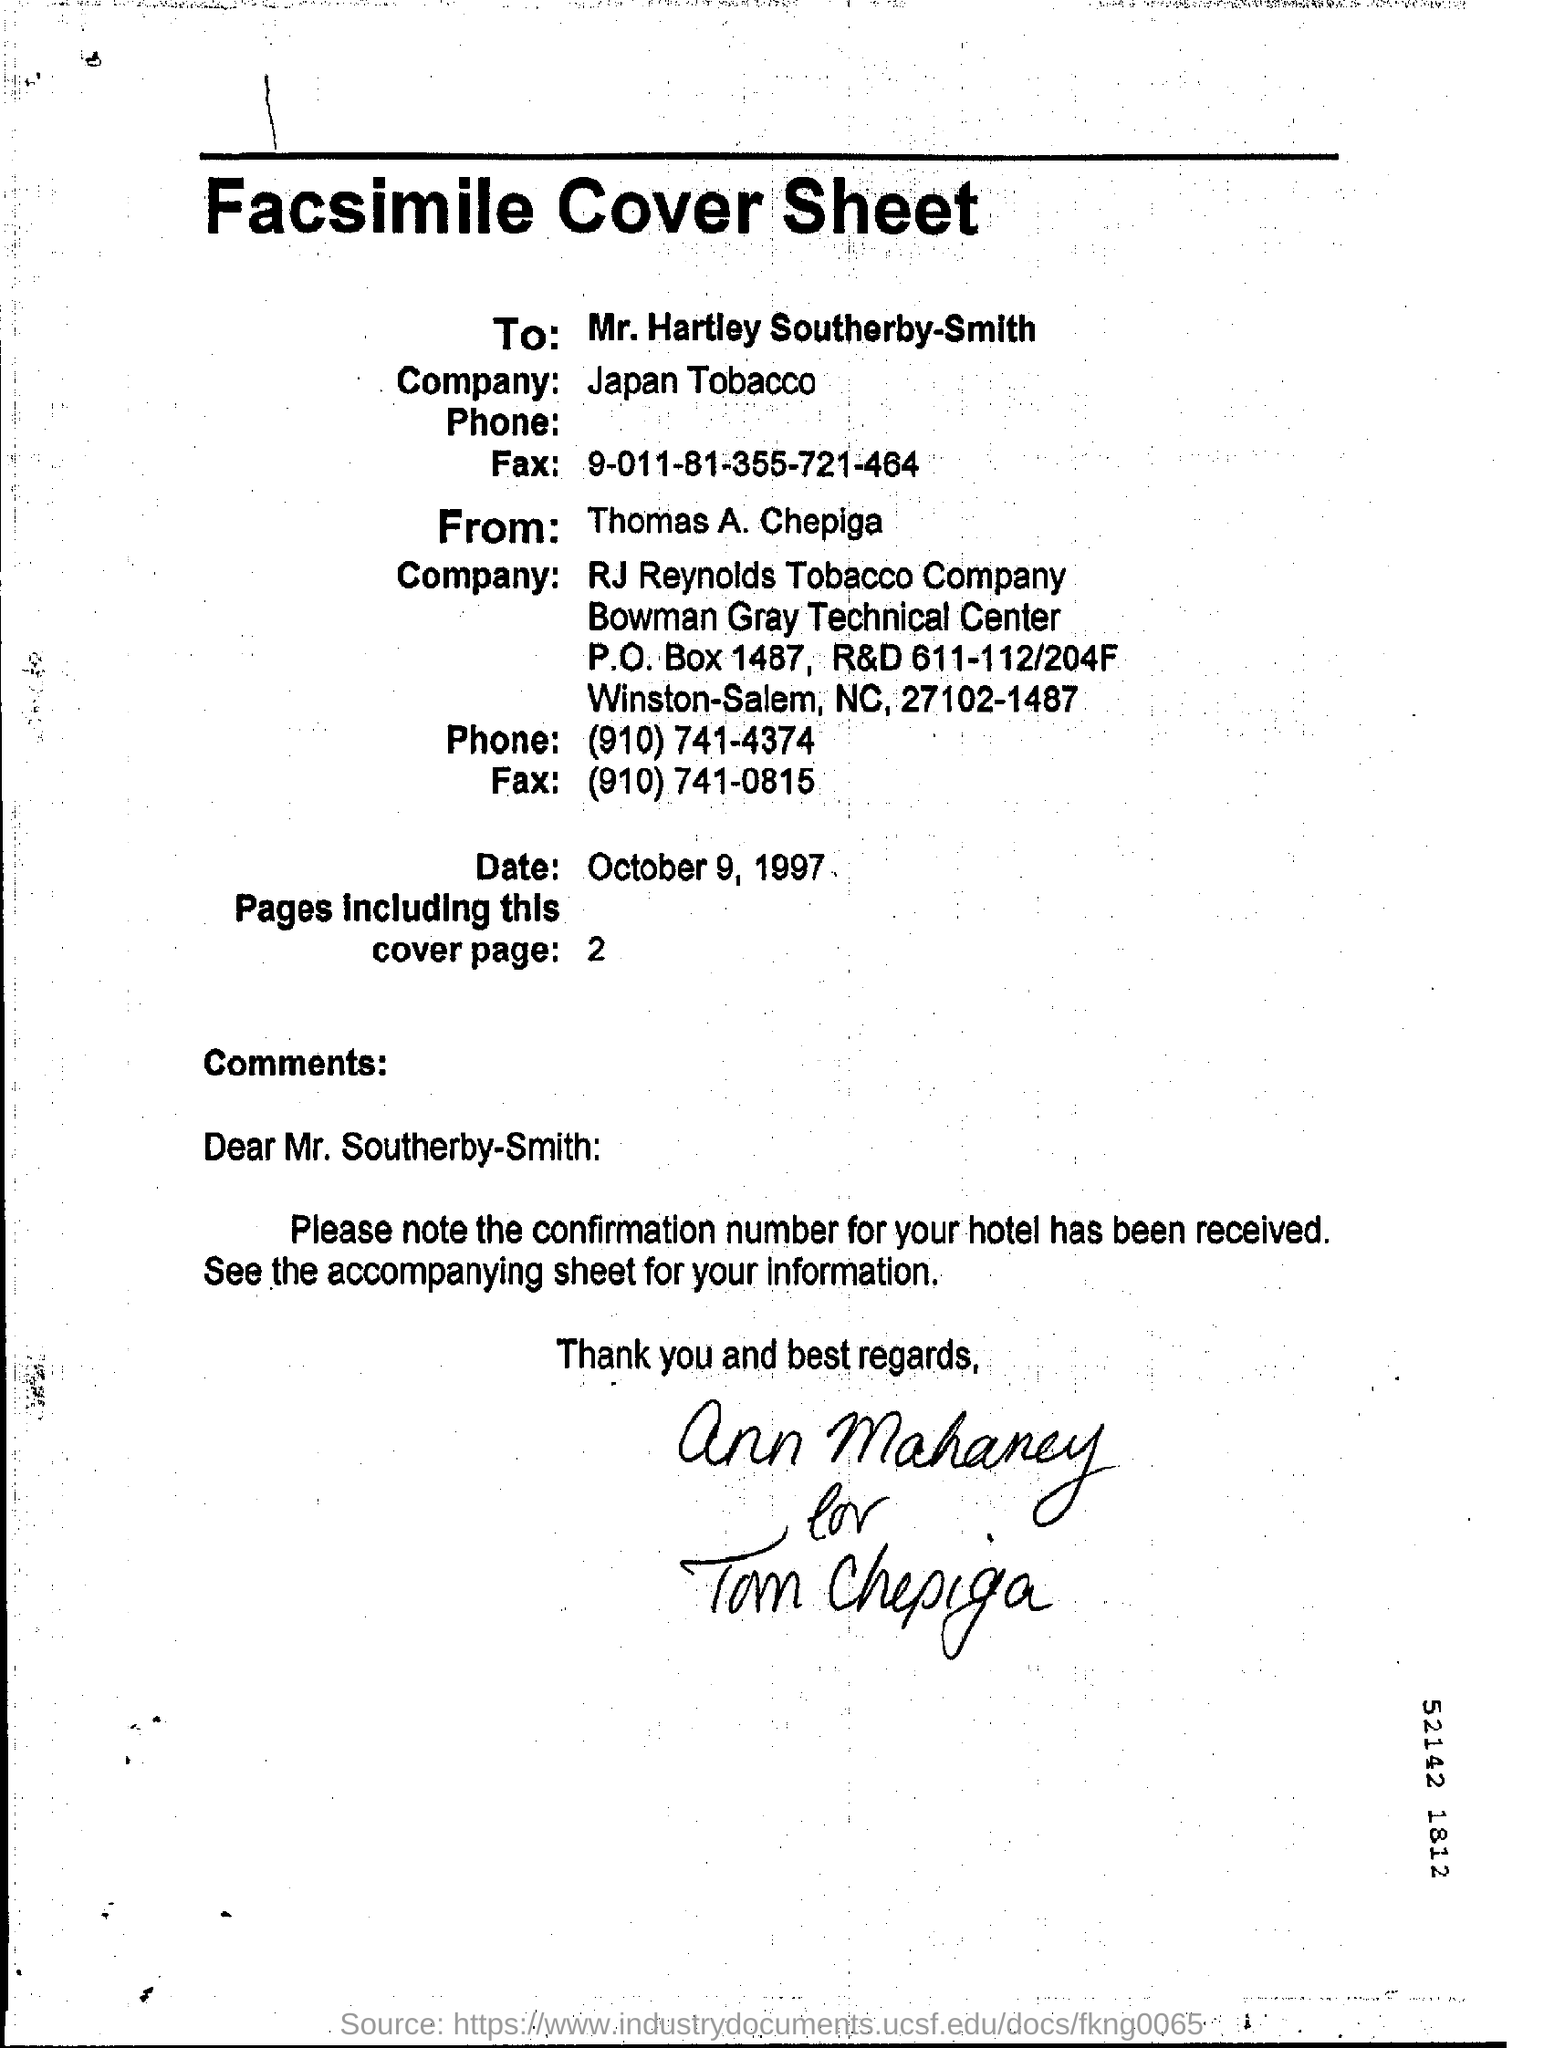What type of cover sheet does the document has as heading
Provide a short and direct response. Facsimile. In the cover sheet whose name is given in the "To" field?
Offer a terse response. Mr.Hartley Southerby-Smith. What "company" name is mentioned in the cover sheet?
Your answer should be very brief. Japan Tobacco. How many pages are included in the cover page
Your answer should be very brief. 2. In the comments who is the addressee?
Your answer should be very brief. Mr.Southerby-Smith. What is the name of the person given in the facsimile cover sheet
Keep it short and to the point. Thomas A. Chepiga. 